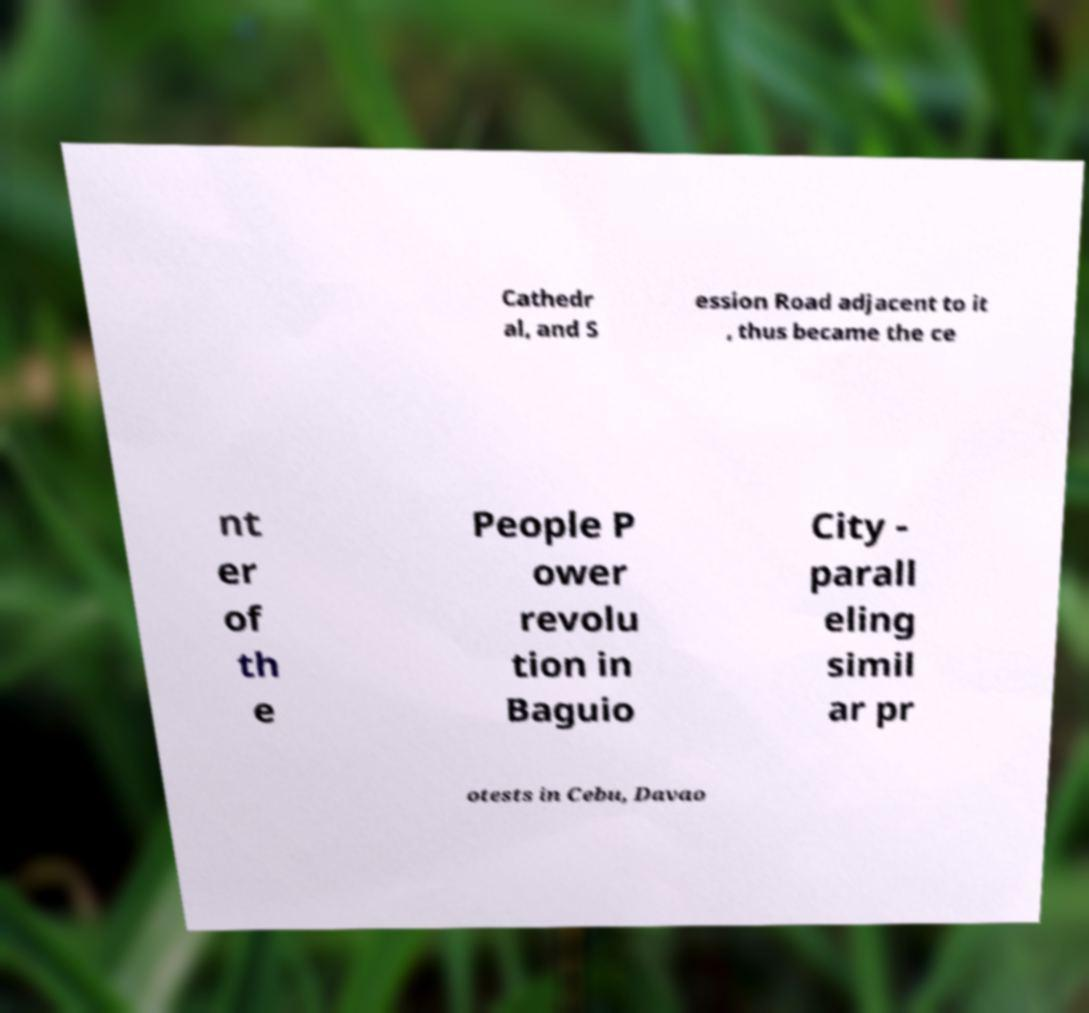For documentation purposes, I need the text within this image transcribed. Could you provide that? Cathedr al, and S ession Road adjacent to it , thus became the ce nt er of th e People P ower revolu tion in Baguio City - parall eling simil ar pr otests in Cebu, Davao 